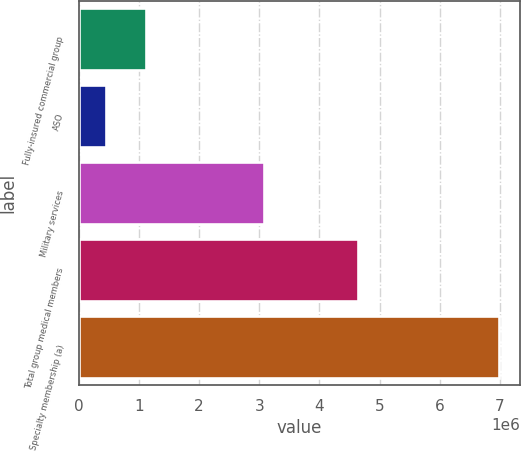<chart> <loc_0><loc_0><loc_500><loc_500><bar_chart><fcel>Fully-insured commercial group<fcel>ASO<fcel>Military services<fcel>Total group medical members<fcel>Specialty membership (a)<nl><fcel>1.11143e+06<fcel>458700<fcel>3.0818e+06<fcel>4.6382e+06<fcel>6.986e+06<nl></chart> 